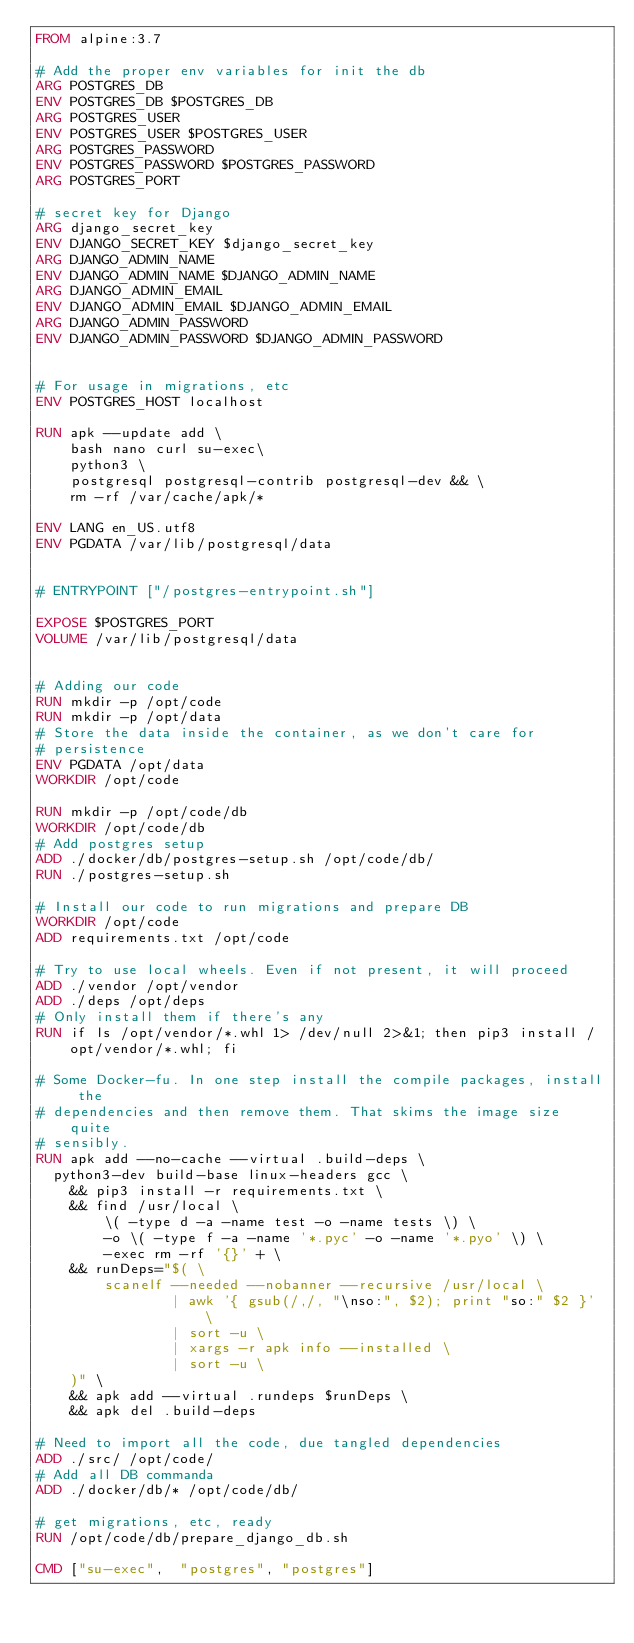Convert code to text. <code><loc_0><loc_0><loc_500><loc_500><_Dockerfile_>FROM alpine:3.7

# Add the proper env variables for init the db
ARG POSTGRES_DB
ENV POSTGRES_DB $POSTGRES_DB
ARG POSTGRES_USER
ENV POSTGRES_USER $POSTGRES_USER
ARG POSTGRES_PASSWORD
ENV POSTGRES_PASSWORD $POSTGRES_PASSWORD
ARG POSTGRES_PORT

# secret key for Django
ARG django_secret_key
ENV DJANGO_SECRET_KEY $django_secret_key
ARG DJANGO_ADMIN_NAME
ENV DJANGO_ADMIN_NAME $DJANGO_ADMIN_NAME
ARG DJANGO_ADMIN_EMAIL
ENV DJANGO_ADMIN_EMAIL $DJANGO_ADMIN_EMAIL
ARG DJANGO_ADMIN_PASSWORD
ENV DJANGO_ADMIN_PASSWORD $DJANGO_ADMIN_PASSWORD


# For usage in migrations, etc
ENV POSTGRES_HOST localhost

RUN apk --update add \
    bash nano curl su-exec\
    python3 \
    postgresql postgresql-contrib postgresql-dev && \
    rm -rf /var/cache/apk/*

ENV LANG en_US.utf8
ENV PGDATA /var/lib/postgresql/data


# ENTRYPOINT ["/postgres-entrypoint.sh"]

EXPOSE $POSTGRES_PORT
VOLUME /var/lib/postgresql/data


# Adding our code
RUN mkdir -p /opt/code
RUN mkdir -p /opt/data
# Store the data inside the container, as we don't care for
# persistence
ENV PGDATA /opt/data
WORKDIR /opt/code

RUN mkdir -p /opt/code/db
WORKDIR /opt/code/db
# Add postgres setup
ADD ./docker/db/postgres-setup.sh /opt/code/db/
RUN ./postgres-setup.sh

# Install our code to run migrations and prepare DB
WORKDIR /opt/code
ADD requirements.txt /opt/code

# Try to use local wheels. Even if not present, it will proceed
ADD ./vendor /opt/vendor
ADD ./deps /opt/deps
# Only install them if there's any
RUN if ls /opt/vendor/*.whl 1> /dev/null 2>&1; then pip3 install /opt/vendor/*.whl; fi

# Some Docker-fu. In one step install the compile packages, install the
# dependencies and then remove them. That skims the image size quite
# sensibly.
RUN apk add --no-cache --virtual .build-deps \
  python3-dev build-base linux-headers gcc \
    && pip3 install -r requirements.txt \
    && find /usr/local \
        \( -type d -a -name test -o -name tests \) \
        -o \( -type f -a -name '*.pyc' -o -name '*.pyo' \) \
        -exec rm -rf '{}' + \
    && runDeps="$( \
        scanelf --needed --nobanner --recursive /usr/local \
                | awk '{ gsub(/,/, "\nso:", $2); print "so:" $2 }' \
                | sort -u \
                | xargs -r apk info --installed \
                | sort -u \
    )" \
    && apk add --virtual .rundeps $runDeps \
    && apk del .build-deps

# Need to import all the code, due tangled dependencies
ADD ./src/ /opt/code/
# Add all DB commanda
ADD ./docker/db/* /opt/code/db/

# get migrations, etc, ready
RUN /opt/code/db/prepare_django_db.sh

CMD ["su-exec",  "postgres", "postgres"]
</code> 